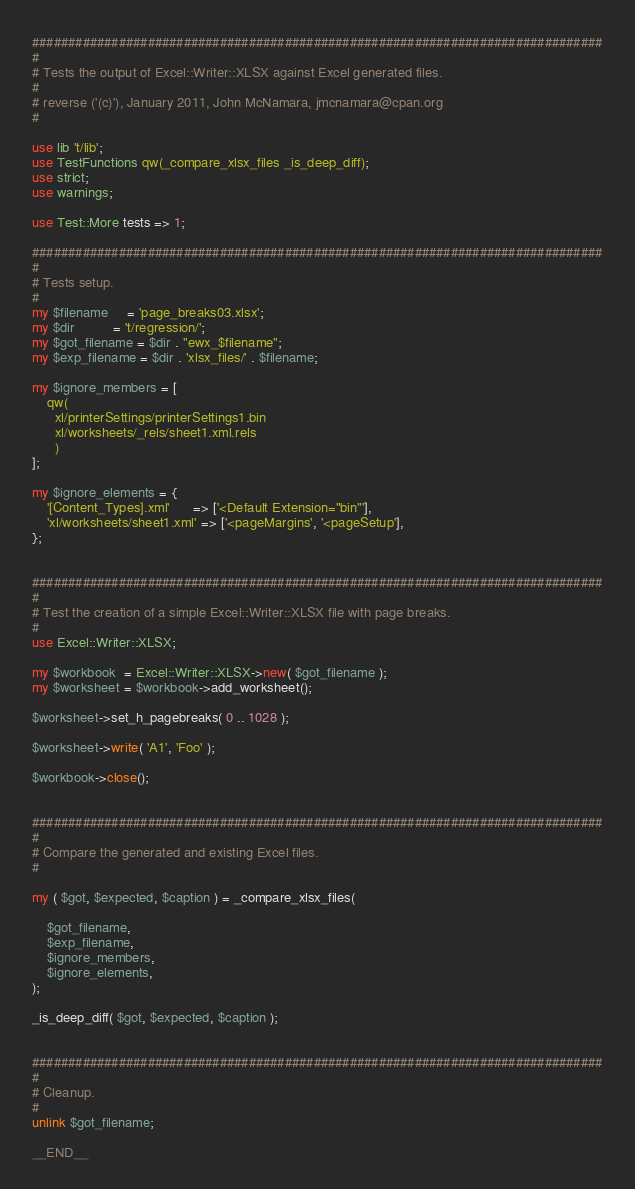Convert code to text. <code><loc_0><loc_0><loc_500><loc_500><_Perl_>###############################################################################
#
# Tests the output of Excel::Writer::XLSX against Excel generated files.
#
# reverse ('(c)'), January 2011, John McNamara, jmcnamara@cpan.org
#

use lib 't/lib';
use TestFunctions qw(_compare_xlsx_files _is_deep_diff);
use strict;
use warnings;

use Test::More tests => 1;

###############################################################################
#
# Tests setup.
#
my $filename     = 'page_breaks03.xlsx';
my $dir          = 't/regression/';
my $got_filename = $dir . "ewx_$filename";
my $exp_filename = $dir . 'xlsx_files/' . $filename;

my $ignore_members = [
    qw(
      xl/printerSettings/printerSettings1.bin
      xl/worksheets/_rels/sheet1.xml.rels
      )
];

my $ignore_elements = {
    '[Content_Types].xml'      => ['<Default Extension="bin"'],
    'xl/worksheets/sheet1.xml' => ['<pageMargins', '<pageSetup'],
};


###############################################################################
#
# Test the creation of a simple Excel::Writer::XLSX file with page breaks.
#
use Excel::Writer::XLSX;

my $workbook  = Excel::Writer::XLSX->new( $got_filename );
my $worksheet = $workbook->add_worksheet();

$worksheet->set_h_pagebreaks( 0 .. 1028 );

$worksheet->write( 'A1', 'Foo' );

$workbook->close();


###############################################################################
#
# Compare the generated and existing Excel files.
#

my ( $got, $expected, $caption ) = _compare_xlsx_files(

    $got_filename,
    $exp_filename,
    $ignore_members,
    $ignore_elements,
);

_is_deep_diff( $got, $expected, $caption );


###############################################################################
#
# Cleanup.
#
unlink $got_filename;

__END__



</code> 